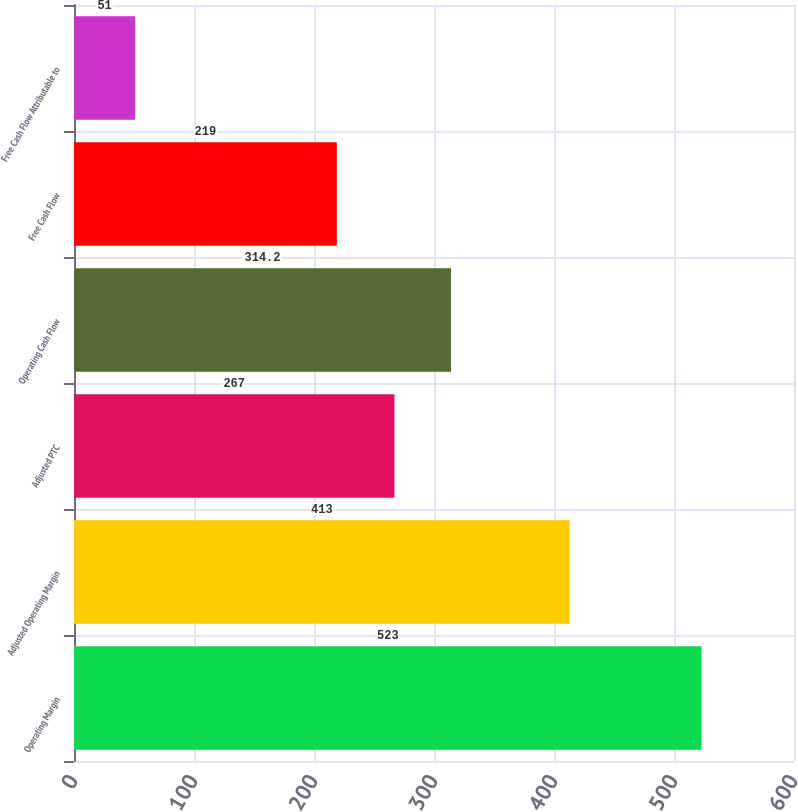Convert chart to OTSL. <chart><loc_0><loc_0><loc_500><loc_500><bar_chart><fcel>Operating Margin<fcel>Adjusted Operating Margin<fcel>Adjusted PTC<fcel>Operating Cash Flow<fcel>Free Cash Flow<fcel>Free Cash Flow Attributable to<nl><fcel>523<fcel>413<fcel>267<fcel>314.2<fcel>219<fcel>51<nl></chart> 